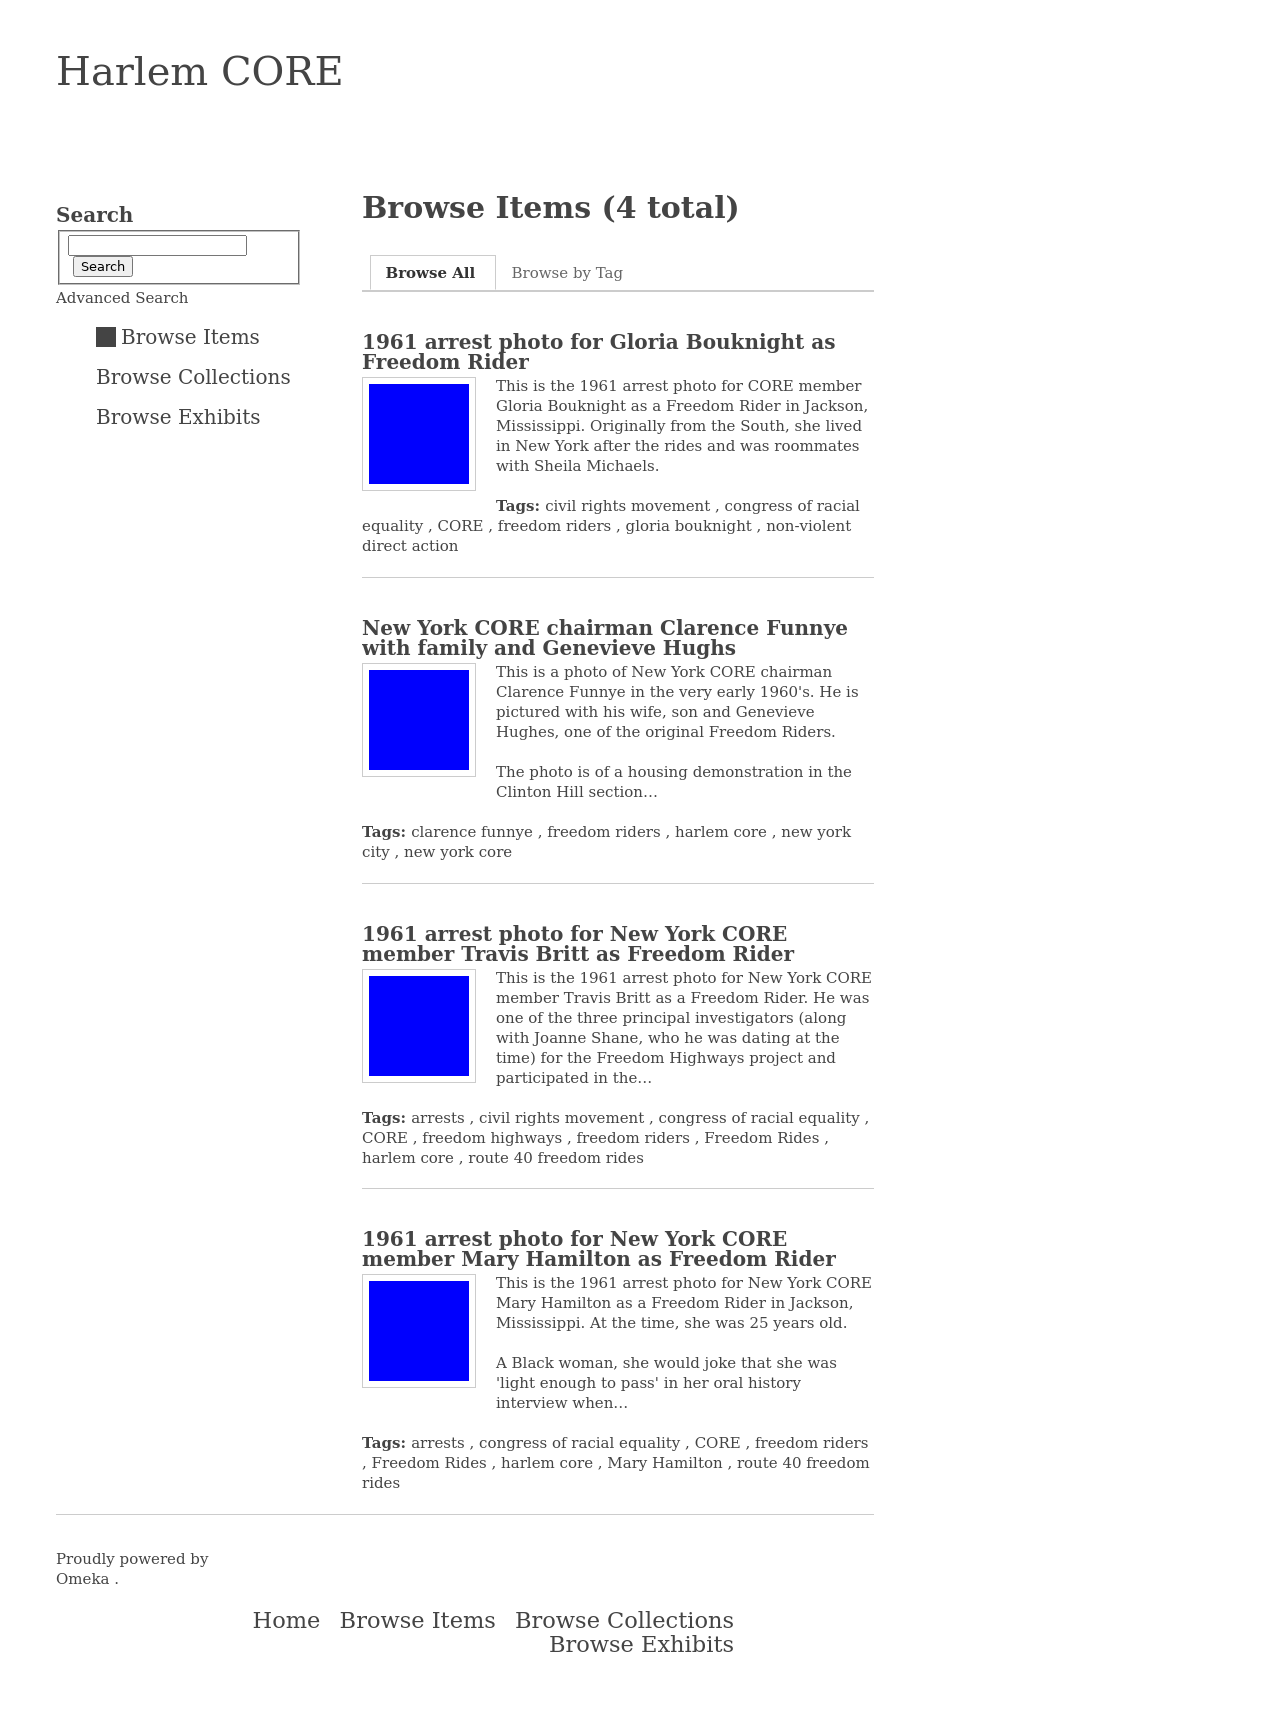Can you tell me more about the history of Gloria Bouknight and her role as a Freedom Rider? Gloria Bouknight was a member of the Congress of Racial Equality (CORE) who participated in the Freedom Rides, a series of protests against segregationist policies in the Southern United States. As a Freedom Rider, Bouknight was among the brave individuals who rode interstate buses into the segregated Southern states to challenge the non-enforcement of Supreme Court decisions which ruled that segregated public buses were unconstitutional. Her arrest photo from 1961, as shown in the image, signifies her involvement and sacrifice in the civil rights movement. 